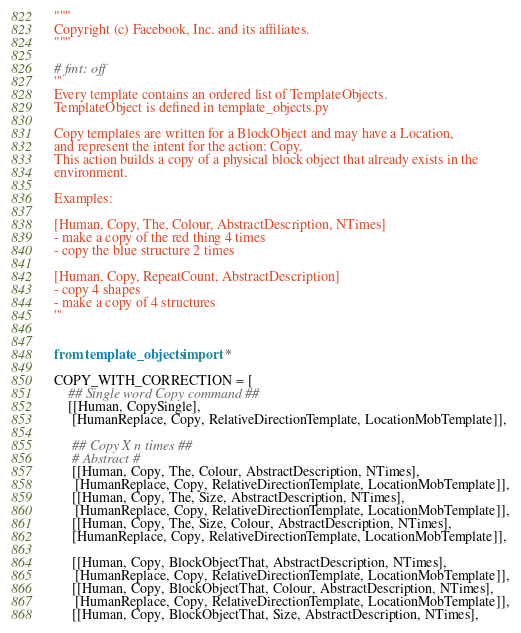Convert code to text. <code><loc_0><loc_0><loc_500><loc_500><_Python_>"""
Copyright (c) Facebook, Inc. and its affiliates.
"""

# fmt: off
'''
Every template contains an ordered list of TemplateObjects.
TemplateObject is defined in template_objects.py

Copy templates are written for a BlockObject and may have a Location,
and represent the intent for the action: Copy.
This action builds a copy of a physical block object that already exists in the
environment.

Examples:

[Human, Copy, The, Colour, AbstractDescription, NTimes]
- make a copy of the red thing 4 times
- copy the blue structure 2 times

[Human, Copy, RepeatCount, AbstractDescription]
- copy 4 shapes
- make a copy of 4 structures
'''


from template_objects import *

COPY_WITH_CORRECTION = [
    ## Single word Copy command ##
    [[Human, CopySingle],
     [HumanReplace, Copy, RelativeDirectionTemplate, LocationMobTemplate]],

     ## Copy X n times ##
     # Abstract #
     [[Human, Copy, The, Colour, AbstractDescription, NTimes],
      [HumanReplace, Copy, RelativeDirectionTemplate, LocationMobTemplate]],
     [[Human, Copy, The, Size, AbstractDescription, NTimes],
      [HumanReplace, Copy, RelativeDirectionTemplate, LocationMobTemplate]],
     [[Human, Copy, The, Size, Colour, AbstractDescription, NTimes],
     [HumanReplace, Copy, RelativeDirectionTemplate, LocationMobTemplate]],

     [[Human, Copy, BlockObjectThat, AbstractDescription, NTimes],
      [HumanReplace, Copy, RelativeDirectionTemplate, LocationMobTemplate]],
     [[Human, Copy, BlockObjectThat, Colour, AbstractDescription, NTimes],
      [HumanReplace, Copy, RelativeDirectionTemplate, LocationMobTemplate]],
     [[Human, Copy, BlockObjectThat, Size, AbstractDescription, NTimes],</code> 